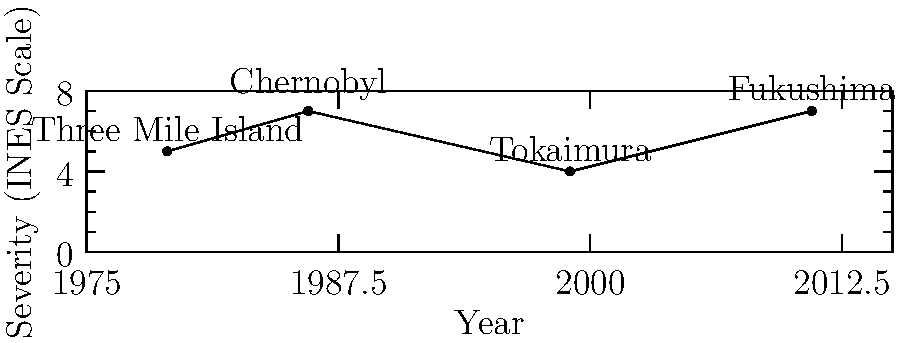Based on the timeline graph of major nuclear power plant incidents, which event occurred closest to the present day and what was its severity rating on the International Nuclear Event Scale (INES)? To answer this question, we need to follow these steps:

1. Identify the events shown on the timeline:
   - Three Mile Island (1979)
   - Chernobyl (1986)
   - Tokaimura (1999)
   - Fukushima (2011)

2. Determine which event is closest to the present day:
   The most recent event on the timeline is Fukushima in 2011.

3. Find the severity rating for the Fukushima incident:
   The graph shows that Fukushima has a severity rating of 7 on the INES scale.

4. Verify the INES scale:
   The y-axis of the graph represents the severity on the INES scale, which ranges from 0 to 7.

5. Conclude:
   The Fukushima incident in 2011 is the most recent event on the timeline, and it has a severity rating of 7, which is the highest on the INES scale.
Answer: Fukushima (2011), severity 7 